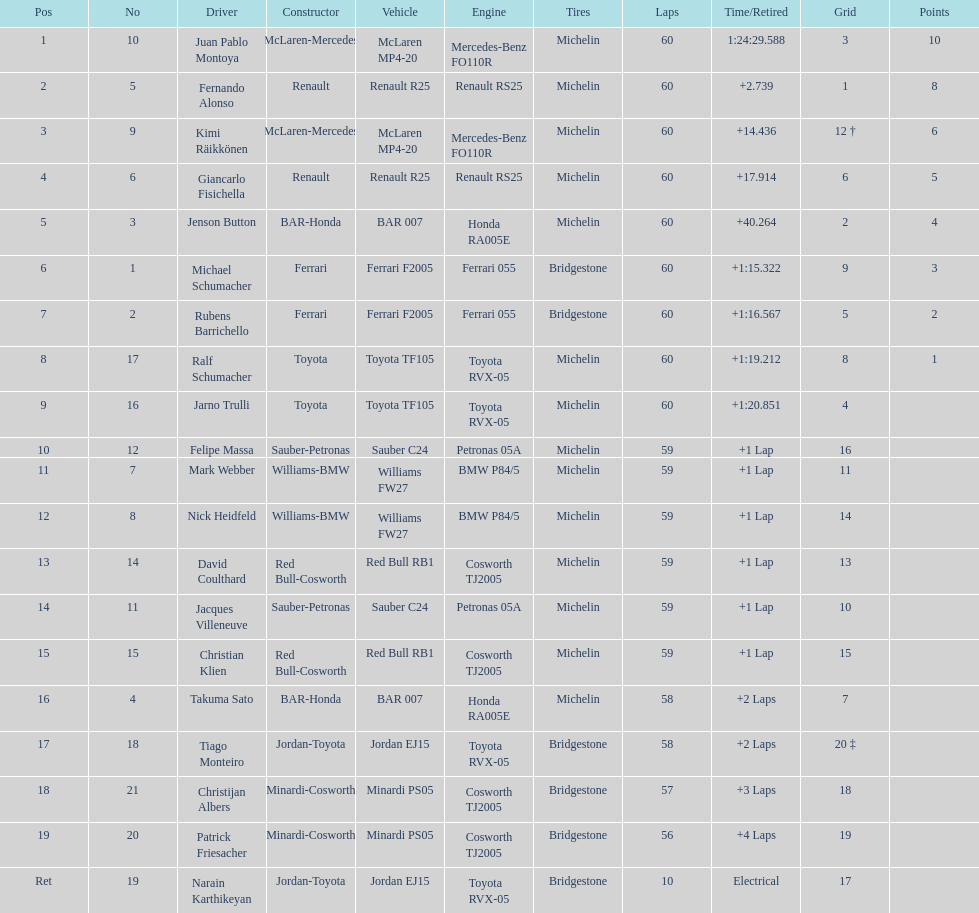Is there a points difference between the 9th position and 19th position on the list? No. 